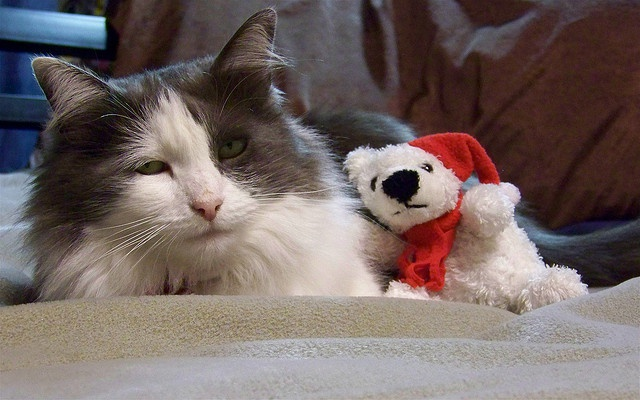Describe the objects in this image and their specific colors. I can see cat in darkblue, black, gray, lightgray, and darkgray tones and teddy bear in darkblue, lightgray, darkgray, brown, and gray tones in this image. 